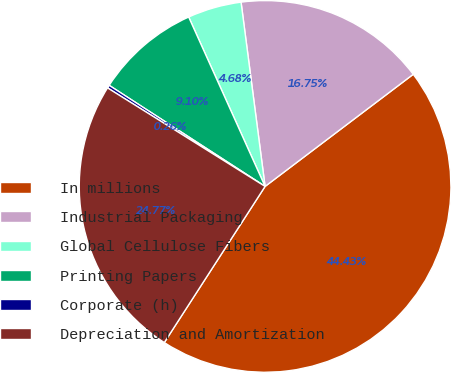Convert chart to OTSL. <chart><loc_0><loc_0><loc_500><loc_500><pie_chart><fcel>In millions<fcel>Industrial Packaging<fcel>Global Cellulose Fibers<fcel>Printing Papers<fcel>Corporate (h)<fcel>Depreciation and Amortization<nl><fcel>44.43%<fcel>16.75%<fcel>4.68%<fcel>9.1%<fcel>0.26%<fcel>24.77%<nl></chart> 